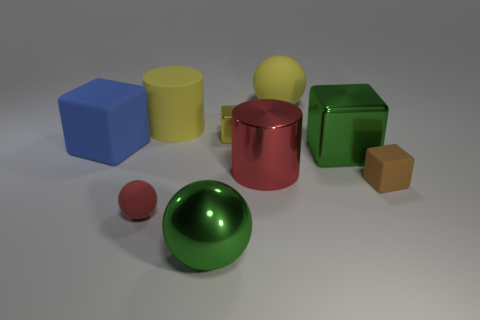What color is the large metallic thing that is the same shape as the small red object?
Your answer should be very brief. Green. How many small things are on the left side of the big yellow object that is in front of the large yellow rubber sphere?
Your answer should be compact. 1. What number of spheres are either big blue metal objects or tiny red objects?
Your answer should be compact. 1. Is there a rubber cylinder?
Offer a terse response. Yes. There is a brown matte thing that is the same shape as the yellow metal object; what is its size?
Keep it short and to the point. Small. What shape is the green metal object behind the red shiny thing in front of the small metallic cube?
Your answer should be compact. Cube. How many green objects are large spheres or large shiny blocks?
Your answer should be compact. 2. What is the color of the small rubber sphere?
Your answer should be very brief. Red. Do the red rubber sphere and the yellow rubber sphere have the same size?
Offer a terse response. No. Is the material of the red ball the same as the big blue thing that is in front of the big yellow cylinder?
Ensure brevity in your answer.  Yes. 